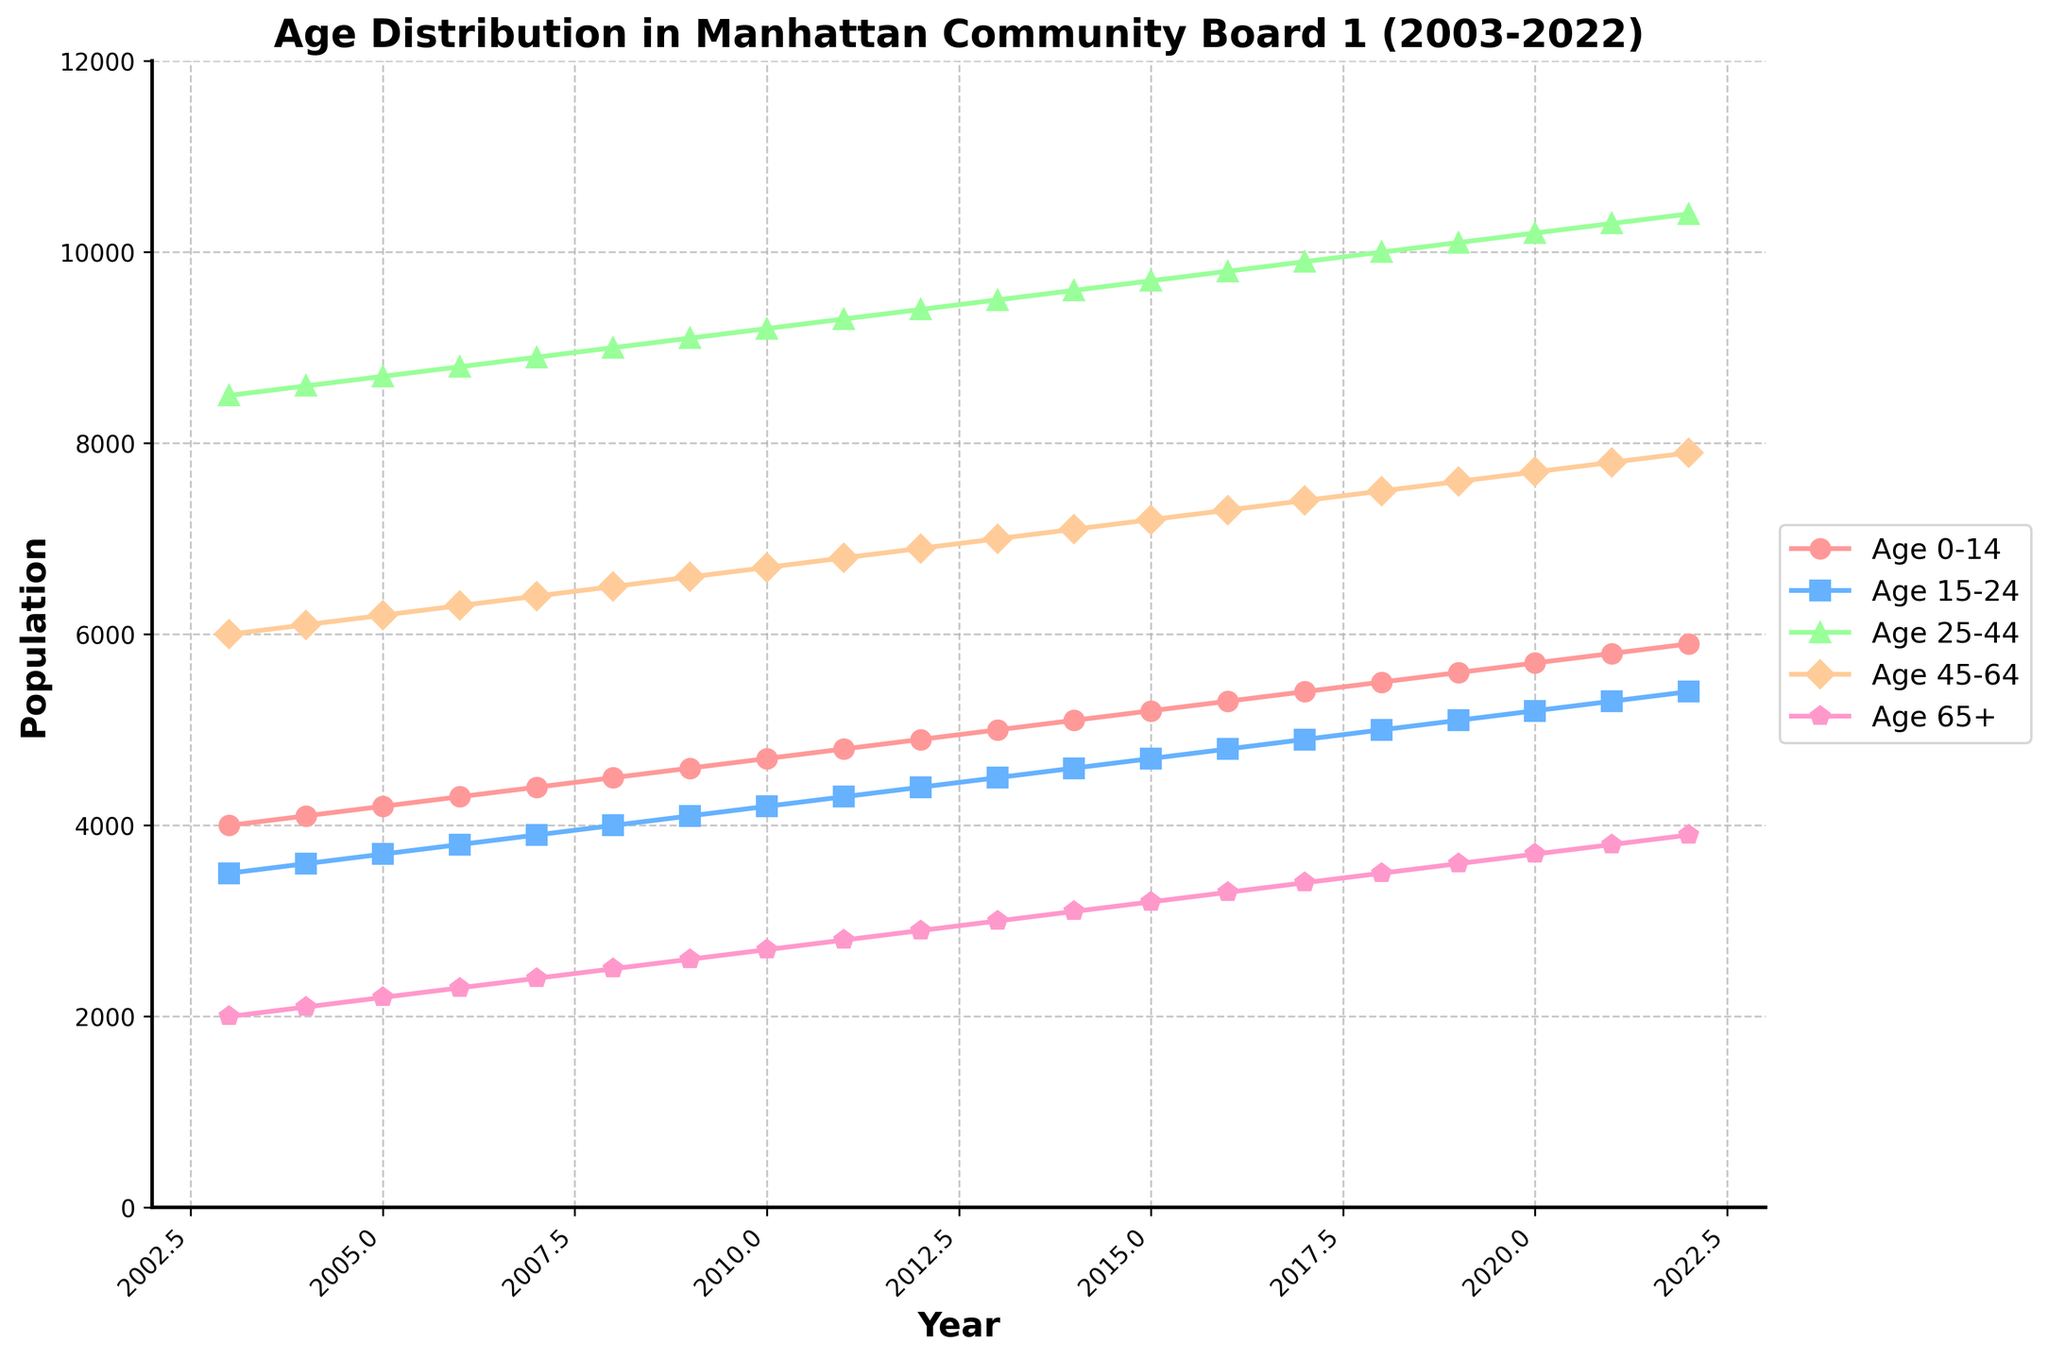What is the title of the figure? Look for the large text usually centered at the top of the plot area. The title provides a summary of what the figure represents.
Answer: Age Distribution in Manhattan Community Board 1 (2003-2022) What are the age groups included in the plot? Identify the different age groups by examining the legend on the right side of the plot.
Answer: Age 0-14, Age 15-24, Age 25-44, Age 45-64, Age 65+ Which age group had the largest population in 2015? Find the data points for 2015 on the x-axis and compare the values for each age group.
Answer: Age 25-44 How did the population of the Age 65+ group change from 2003 to 2022? Look at the value for the Age 65+ group in 2003 and compare it to the value in 2022.
Answer: Increased by 1900 What was the trend for the Age 25-44 group over the 20 years? Observe the plotted line for the Age 25-44 group from the start to the end of the time series. Examine the overall direction and changes in the line.
Answer: Consistently increasing Which age group saw the least amount of change over the 20 years? Compare the trends and the differences between the starting and ending points of each age group's line on the plot.
Answer: Age 0-14 By how much did the population of the Age 0-14 group increase each year on average? Calculate the difference between the population in 2003 and 2022 and then divide by the number of years (19).
Answer: (5900 - 4000) / 19 = 100 What is the overall trend for the Age 45-64 group? Follow the plotted line for the Age 45-64 group and note the general direction from 2003 to 2022.
Answer: Increasing In what year did the Age 15-24 group surpass the population of 5000? Identify when the plotted line for the Age 15-24 group crosses the 5000 mark on the y-axis.
Answer: 2018 In 2010, which age group had the second-highest population? Refer to the data points for 2010 and rank the populations of each age group.
Answer: Age 45-64 